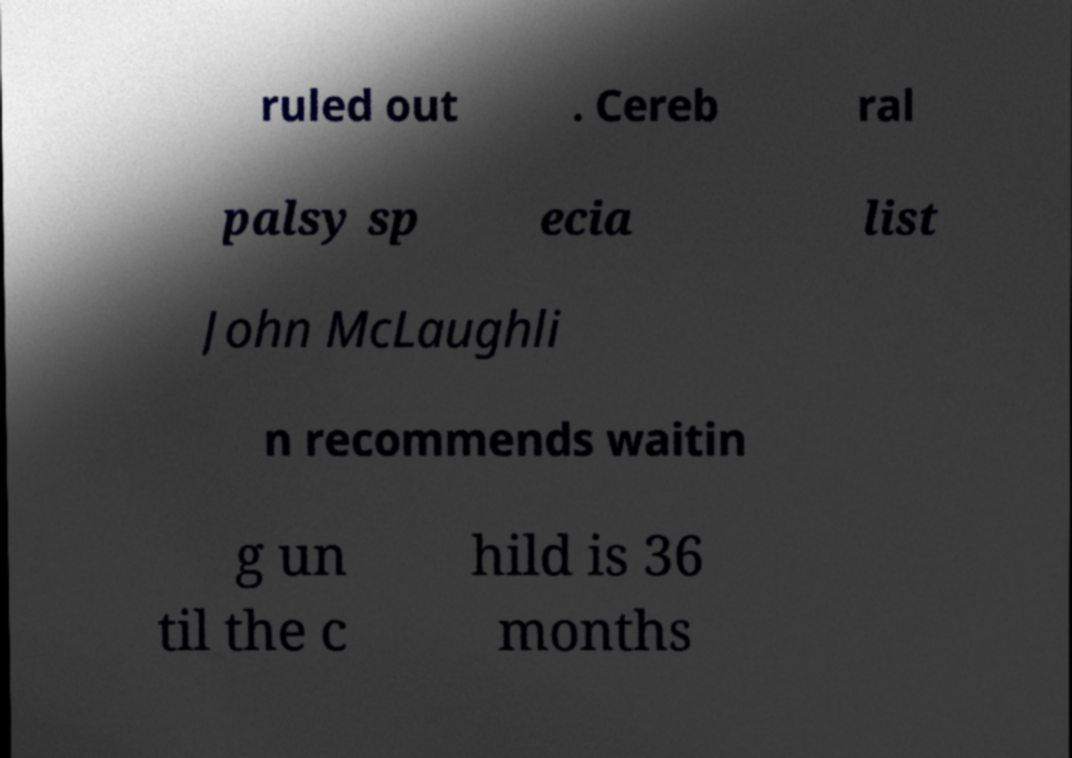I need the written content from this picture converted into text. Can you do that? ruled out . Cereb ral palsy sp ecia list John McLaughli n recommends waitin g un til the c hild is 36 months 